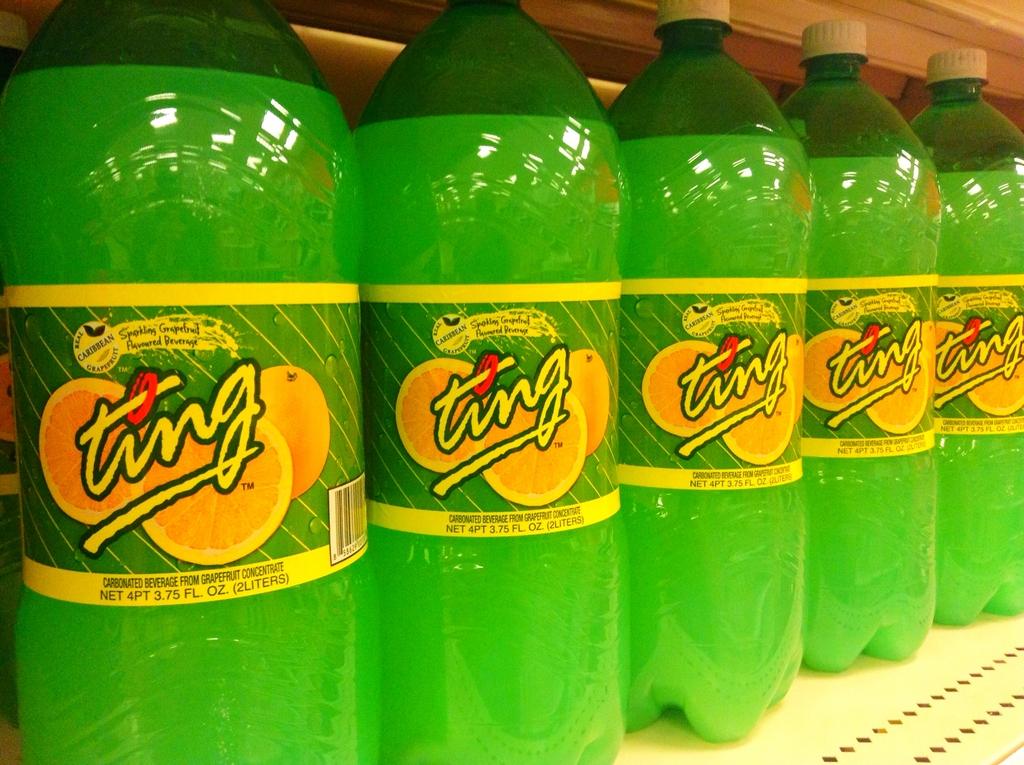How many fluid ounces are in this beverage?
Offer a very short reply. 3.75. What brand of drink is written on the container?
Make the answer very short. Ting. 